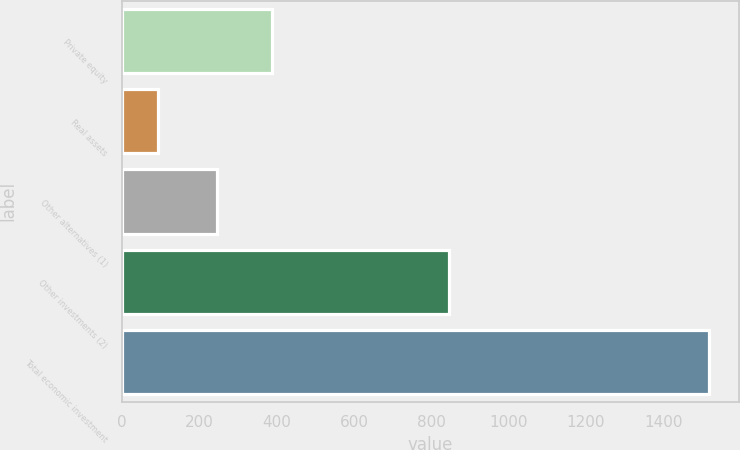Convert chart. <chart><loc_0><loc_0><loc_500><loc_500><bar_chart><fcel>Private equity<fcel>Real assets<fcel>Other alternatives (1)<fcel>Other investments (2)<fcel>Total economic investment<nl><fcel>387.5<fcel>94<fcel>245<fcel>846<fcel>1519<nl></chart> 